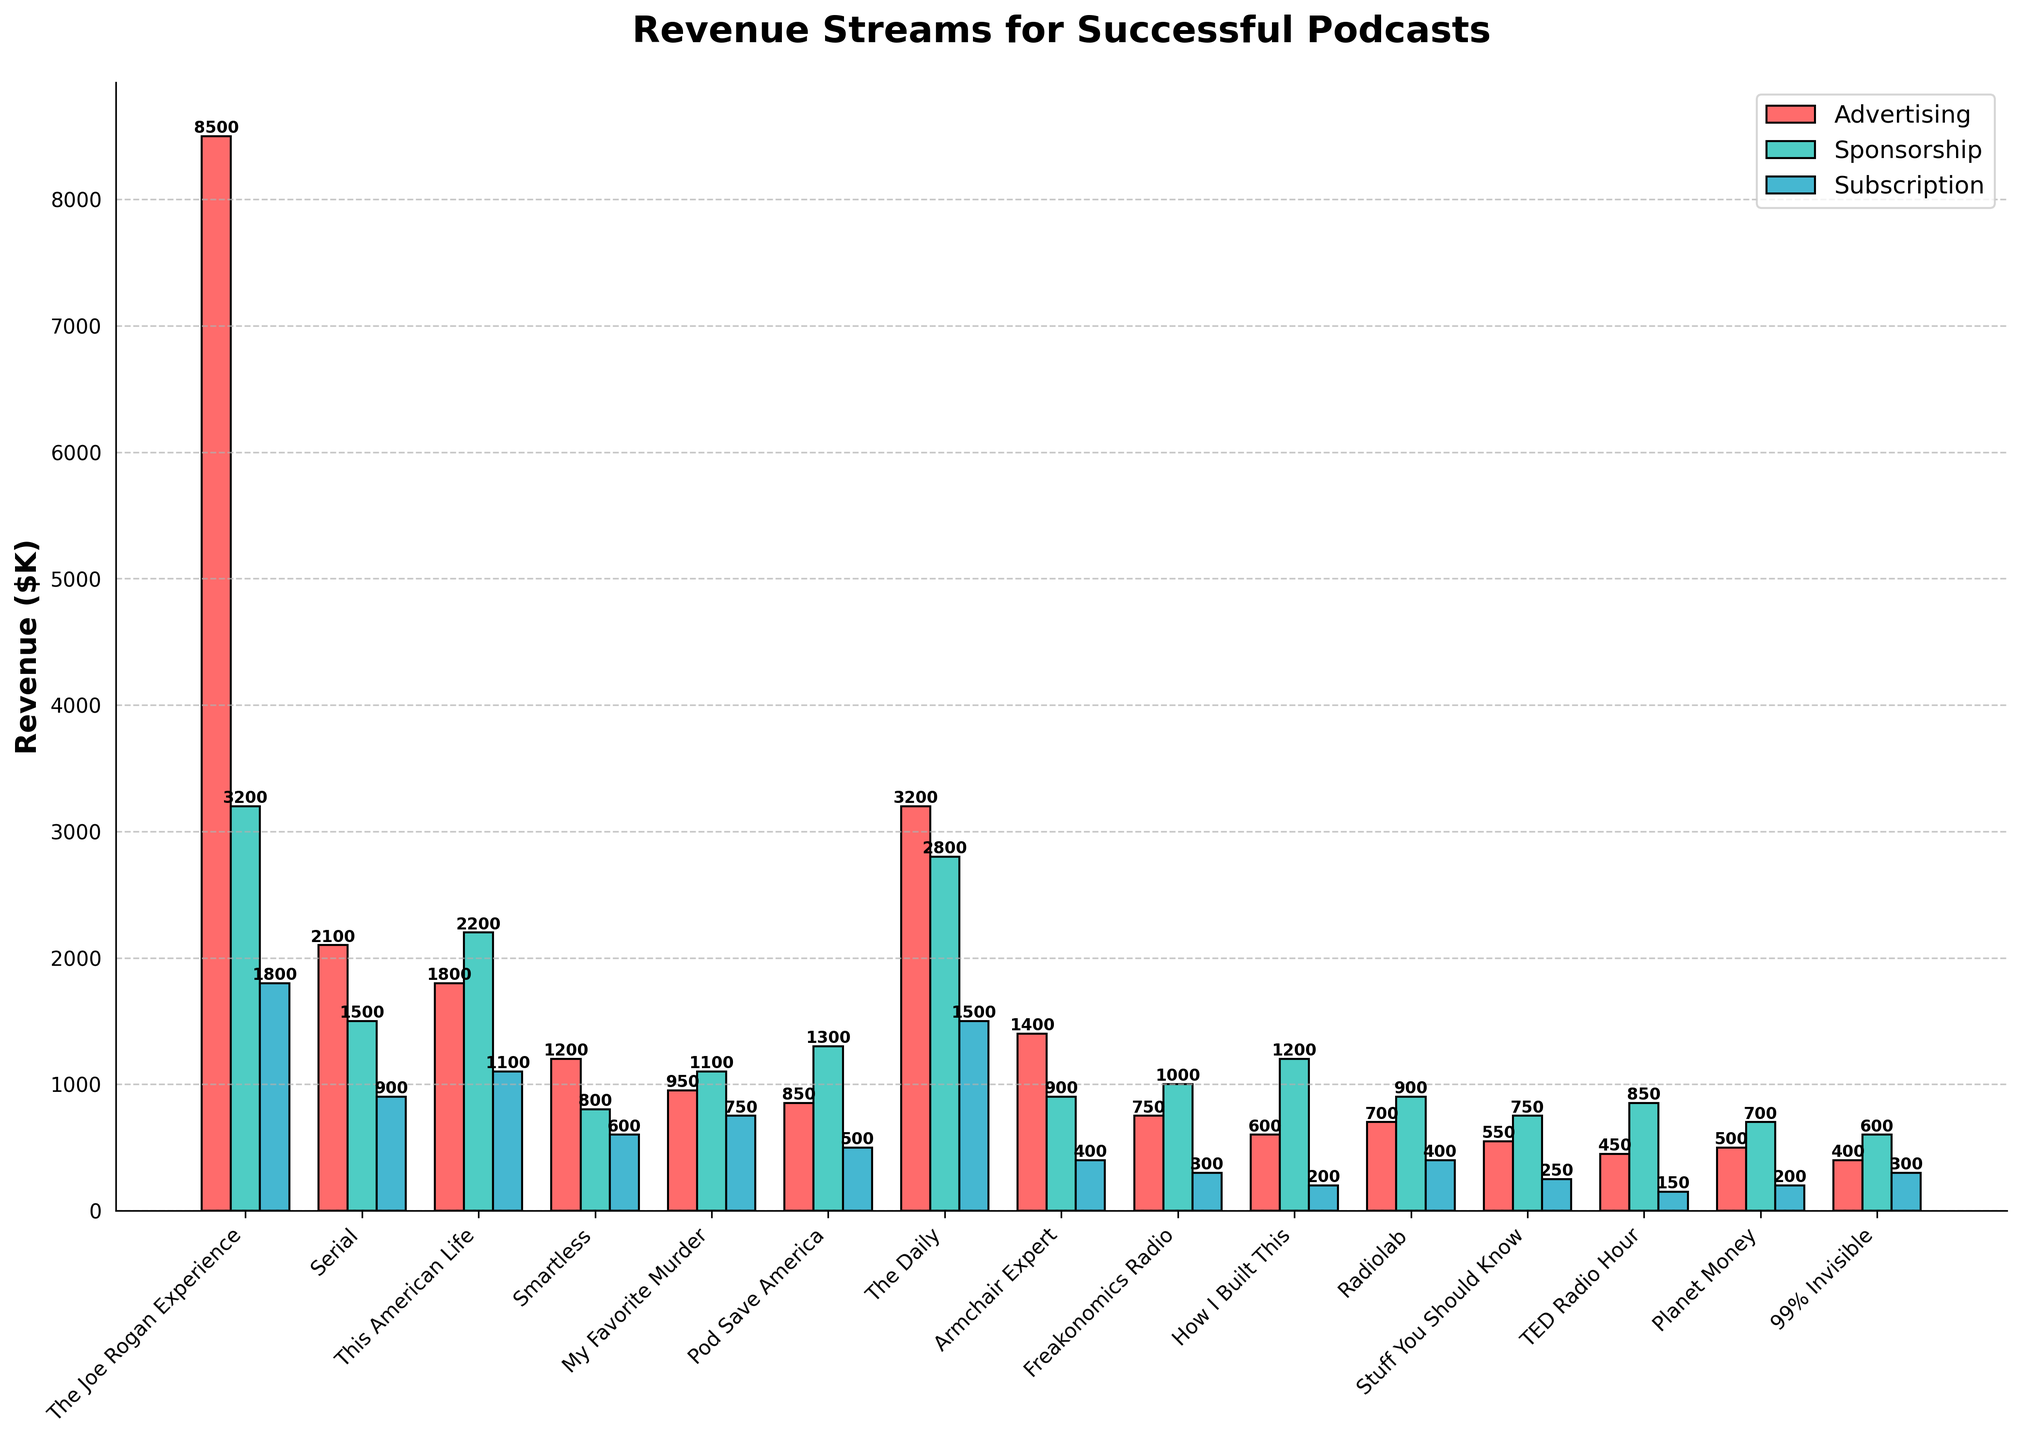Which podcast has the highest advertising revenue? The podcast with the highest advertising revenue has the tallest red bar. "The Joe Rogan Experience" has the tallest red bar.
Answer: The Joe Rogan Experience Which revenue stream is the most consistent across different podcasts? By examining the uniformity of bar heights across podcasts, the subscription revenue (blue bars) appears more consistent, with fewer drastic changes compared to the others.
Answer: Subscription Which podcast has the most balanced revenue streams among advertising, sponsorship, and subscriptions? A balanced revenue stream would have bars of similar height across all three categories. "This American Life" shows relatively similar heights for red, green, and blue bars.
Answer: This American Life What's the total sponsorship revenue for "Serial" and "Freakonomics Radio"? The sponsorship revenue for "Serial" is $1,500K, and for "Freakonomics Radio" is $1,000K. The sum is $1,500K + $1,000K.
Answer: $2,500K How much more advertising revenue does "The Daily" have compared to "Stuff You Should Know"? "The Daily" has an advertising revenue of $3,200K and "Stuff You Should Know" has $550K. The difference is $3,200K - $550K.
Answer: $2,650K Which podcast has the lowest subscription revenue? The lowest subscription revenue corresponds to the podcast with the shortest blue bar. "TED Radio Hour" has the shortest blue bar.
Answer: TED Radio Hour Which two podcasts have the closest overall revenue when combined across all streams? By combining the heights of all bars for each podcast and comparing, "Smartless" and "My Favorite Murder" have similar totals (Smartless: 1200+800+600 = 2600, My Favorite Murder: 950+1100+750 = 2800).
Answer: Smartless and My Favorite Murder What's the average advertising revenue across all podcasts? Sum the advertising revenues: 8500+2100+1800+1200+950+850+3200+1400+750+600+700+550+450+500+400 = 25950K. Divide by the number of podcasts (15).
Answer: $1,730K Which revenue stream contributes the most to the "Armchair Expert" podcast? The tallest bar for "Armchair Expert" indicates the leading revenue stream. The red bar for advertising is the tallest.
Answer: Advertising Compare the sponsorship revenue of "How I Built This" and "Radiolab". The sponsorship revenue for "How I Built This" is $1,200K and for "Radiolab" is $900K. The green bar for "How I Built This" is taller thus higher in sponsorship revenue.
Answer: How I Built This has higher sponsorship revenue 